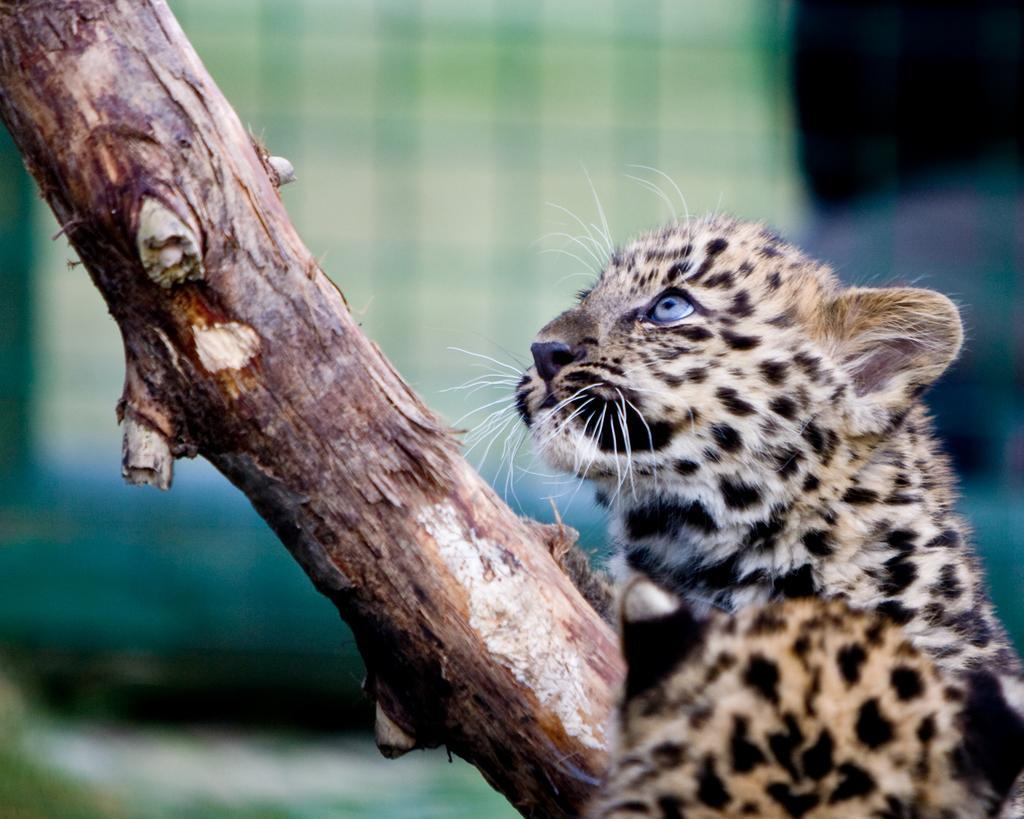What type of living creature is in the image? There is an animal in the image. Where is the animal located in the image? The animal is on the right side of the image. What else can be seen in the image besides the animal? There is a tree trunk in the image. What type of pancake is the animal eating in the image? There is no pancake present in the image, and the animal is not shown eating anything. 